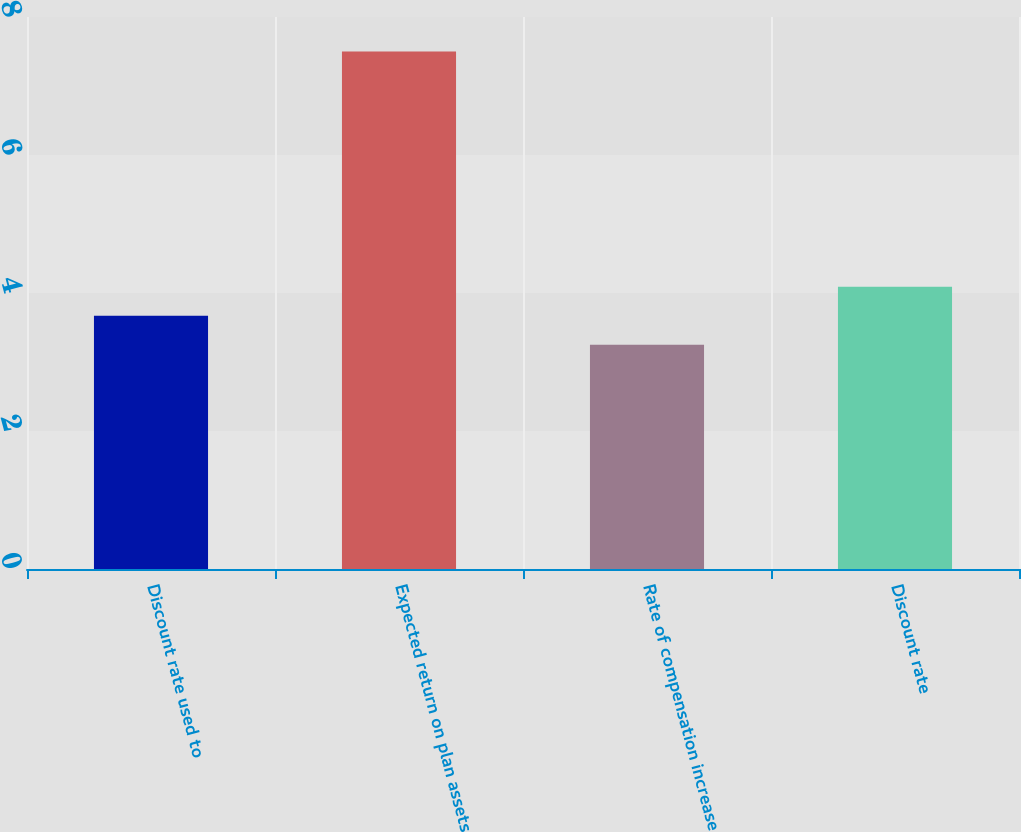Convert chart to OTSL. <chart><loc_0><loc_0><loc_500><loc_500><bar_chart><fcel>Discount rate used to<fcel>Expected return on plan assets<fcel>Rate of compensation increase<fcel>Discount rate<nl><fcel>3.67<fcel>7.5<fcel>3.25<fcel>4.09<nl></chart> 